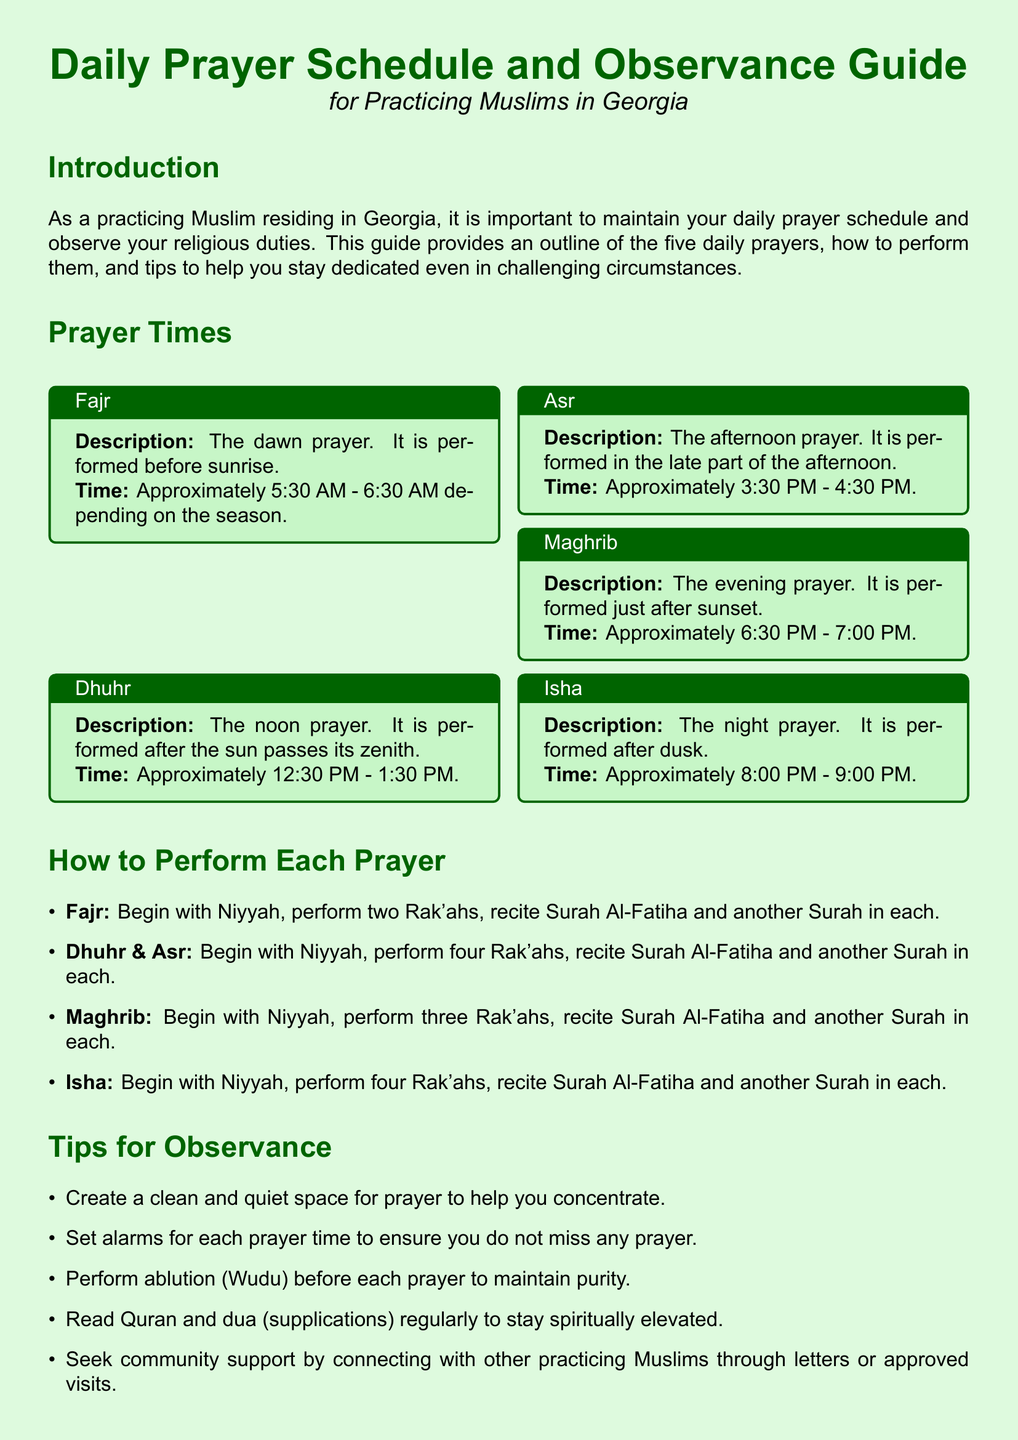What is the first prayer of the day? The first prayer of the day is referenced in the document as the dawn prayer, which is Fajr.
Answer: Fajr What is the time range for Dhuhr prayer? Dhuhr prayer is specified in the document as being performed between 12:30 PM and 1:30 PM.
Answer: Approximately 12:30 PM - 1:30 PM How many Rak'ahs are performed in Maghrib? The number of Rak'ahs for Maghrib prayer, as stated in the document, is three.
Answer: Three What is one tip mentioned for observing prayers? The document lists several tips, one of which is to create a clean and quiet space for prayer.
Answer: Create a clean and quiet space What is the time for Isha prayer? Isha prayer is indicated in the document as being performed between 8:00 PM and 9:00 PM.
Answer: Approximately 8:00 PM - 9:00 PM How many Rak'ahs are there for Asr prayer? As detailed in the document, Asr prayer consists of four Rak'ahs.
Answer: Four What is the color of the document's background? The document specifies the background color as light green.
Answer: Light green How can community support be sought according to the guide? The guide mentions connecting with other practicing Muslims through letters or approved visits for community support.
Answer: Letters or approved visits What should be performed before each prayer? The document advises to perform ablution (Wudu) before each prayer.
Answer: Ablution (Wudu) 